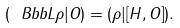<formula> <loc_0><loc_0><loc_500><loc_500>( { \ B b b L } \rho | O ) = ( \rho | [ H , O ] ) .</formula> 